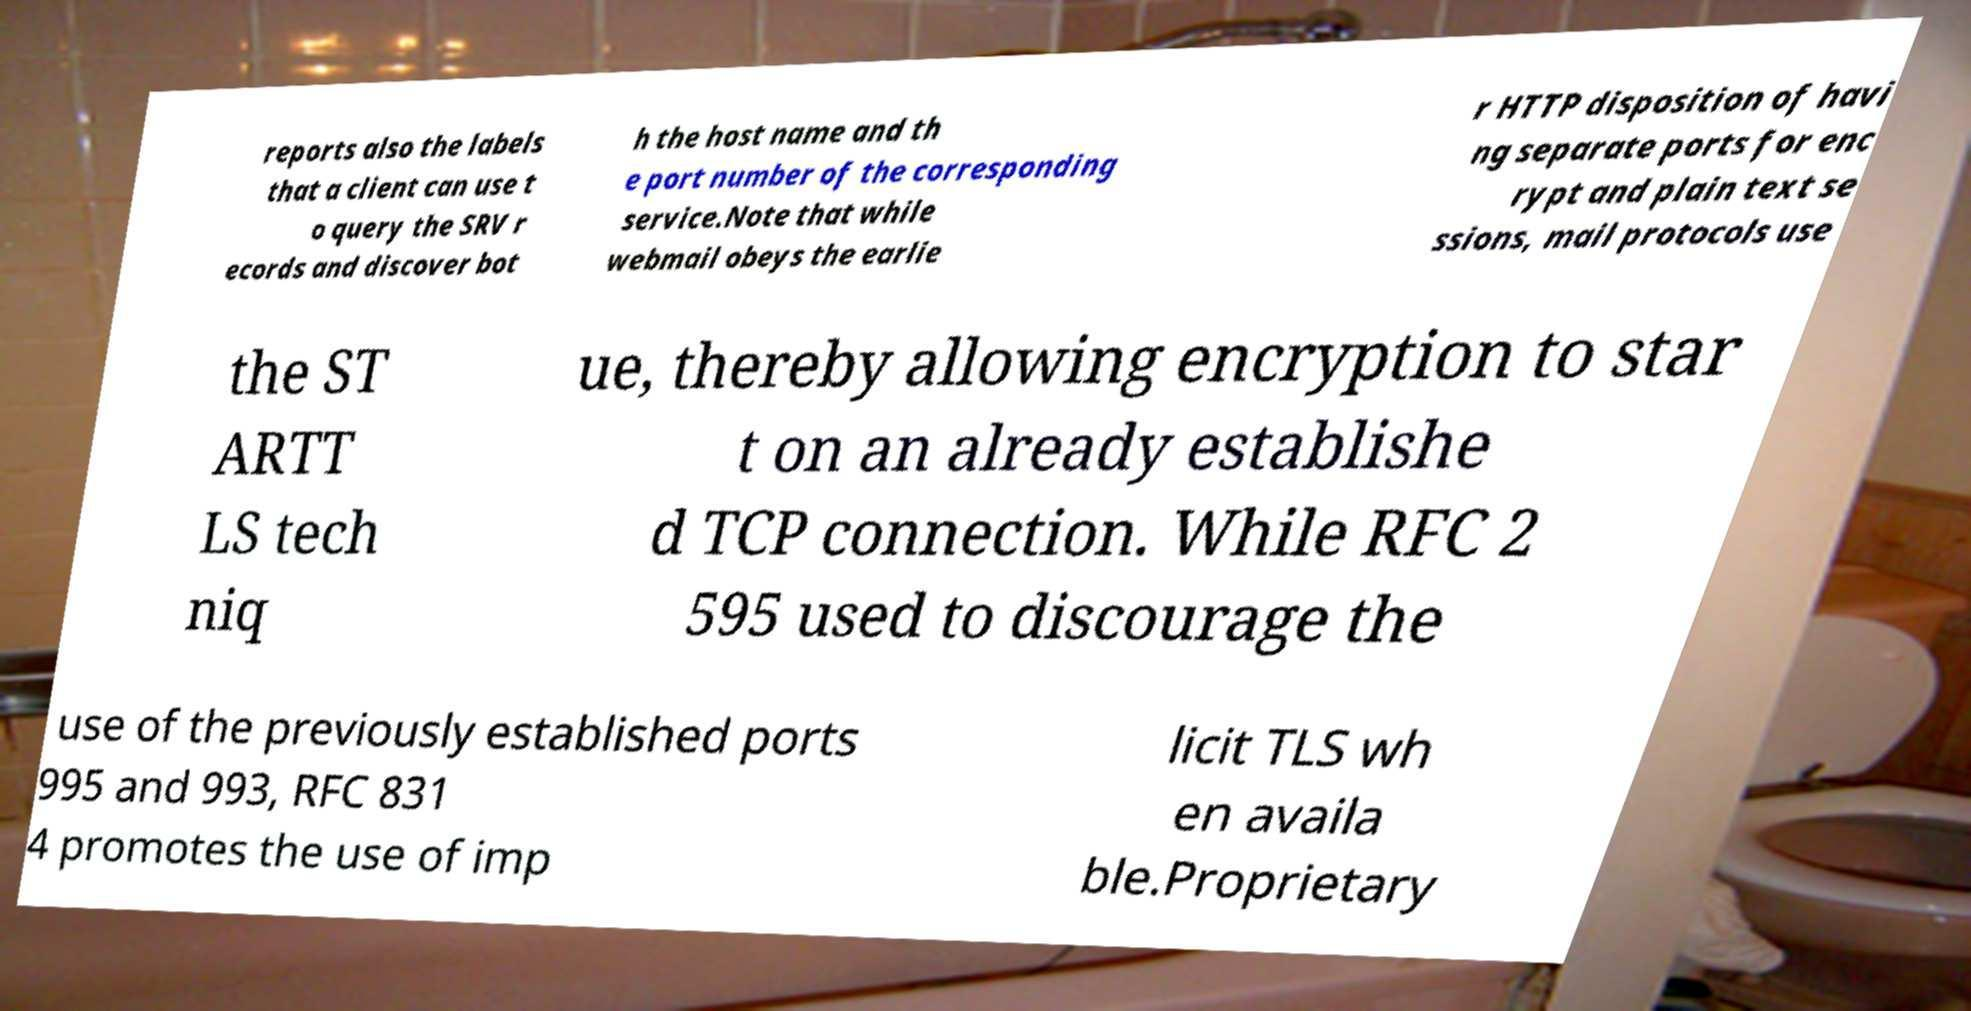I need the written content from this picture converted into text. Can you do that? reports also the labels that a client can use t o query the SRV r ecords and discover bot h the host name and th e port number of the corresponding service.Note that while webmail obeys the earlie r HTTP disposition of havi ng separate ports for enc rypt and plain text se ssions, mail protocols use the ST ARTT LS tech niq ue, thereby allowing encryption to star t on an already establishe d TCP connection. While RFC 2 595 used to discourage the use of the previously established ports 995 and 993, RFC 831 4 promotes the use of imp licit TLS wh en availa ble.Proprietary 